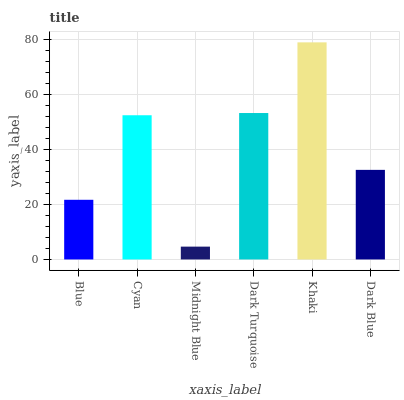Is Midnight Blue the minimum?
Answer yes or no. Yes. Is Khaki the maximum?
Answer yes or no. Yes. Is Cyan the minimum?
Answer yes or no. No. Is Cyan the maximum?
Answer yes or no. No. Is Cyan greater than Blue?
Answer yes or no. Yes. Is Blue less than Cyan?
Answer yes or no. Yes. Is Blue greater than Cyan?
Answer yes or no. No. Is Cyan less than Blue?
Answer yes or no. No. Is Cyan the high median?
Answer yes or no. Yes. Is Dark Blue the low median?
Answer yes or no. Yes. Is Dark Turquoise the high median?
Answer yes or no. No. Is Khaki the low median?
Answer yes or no. No. 